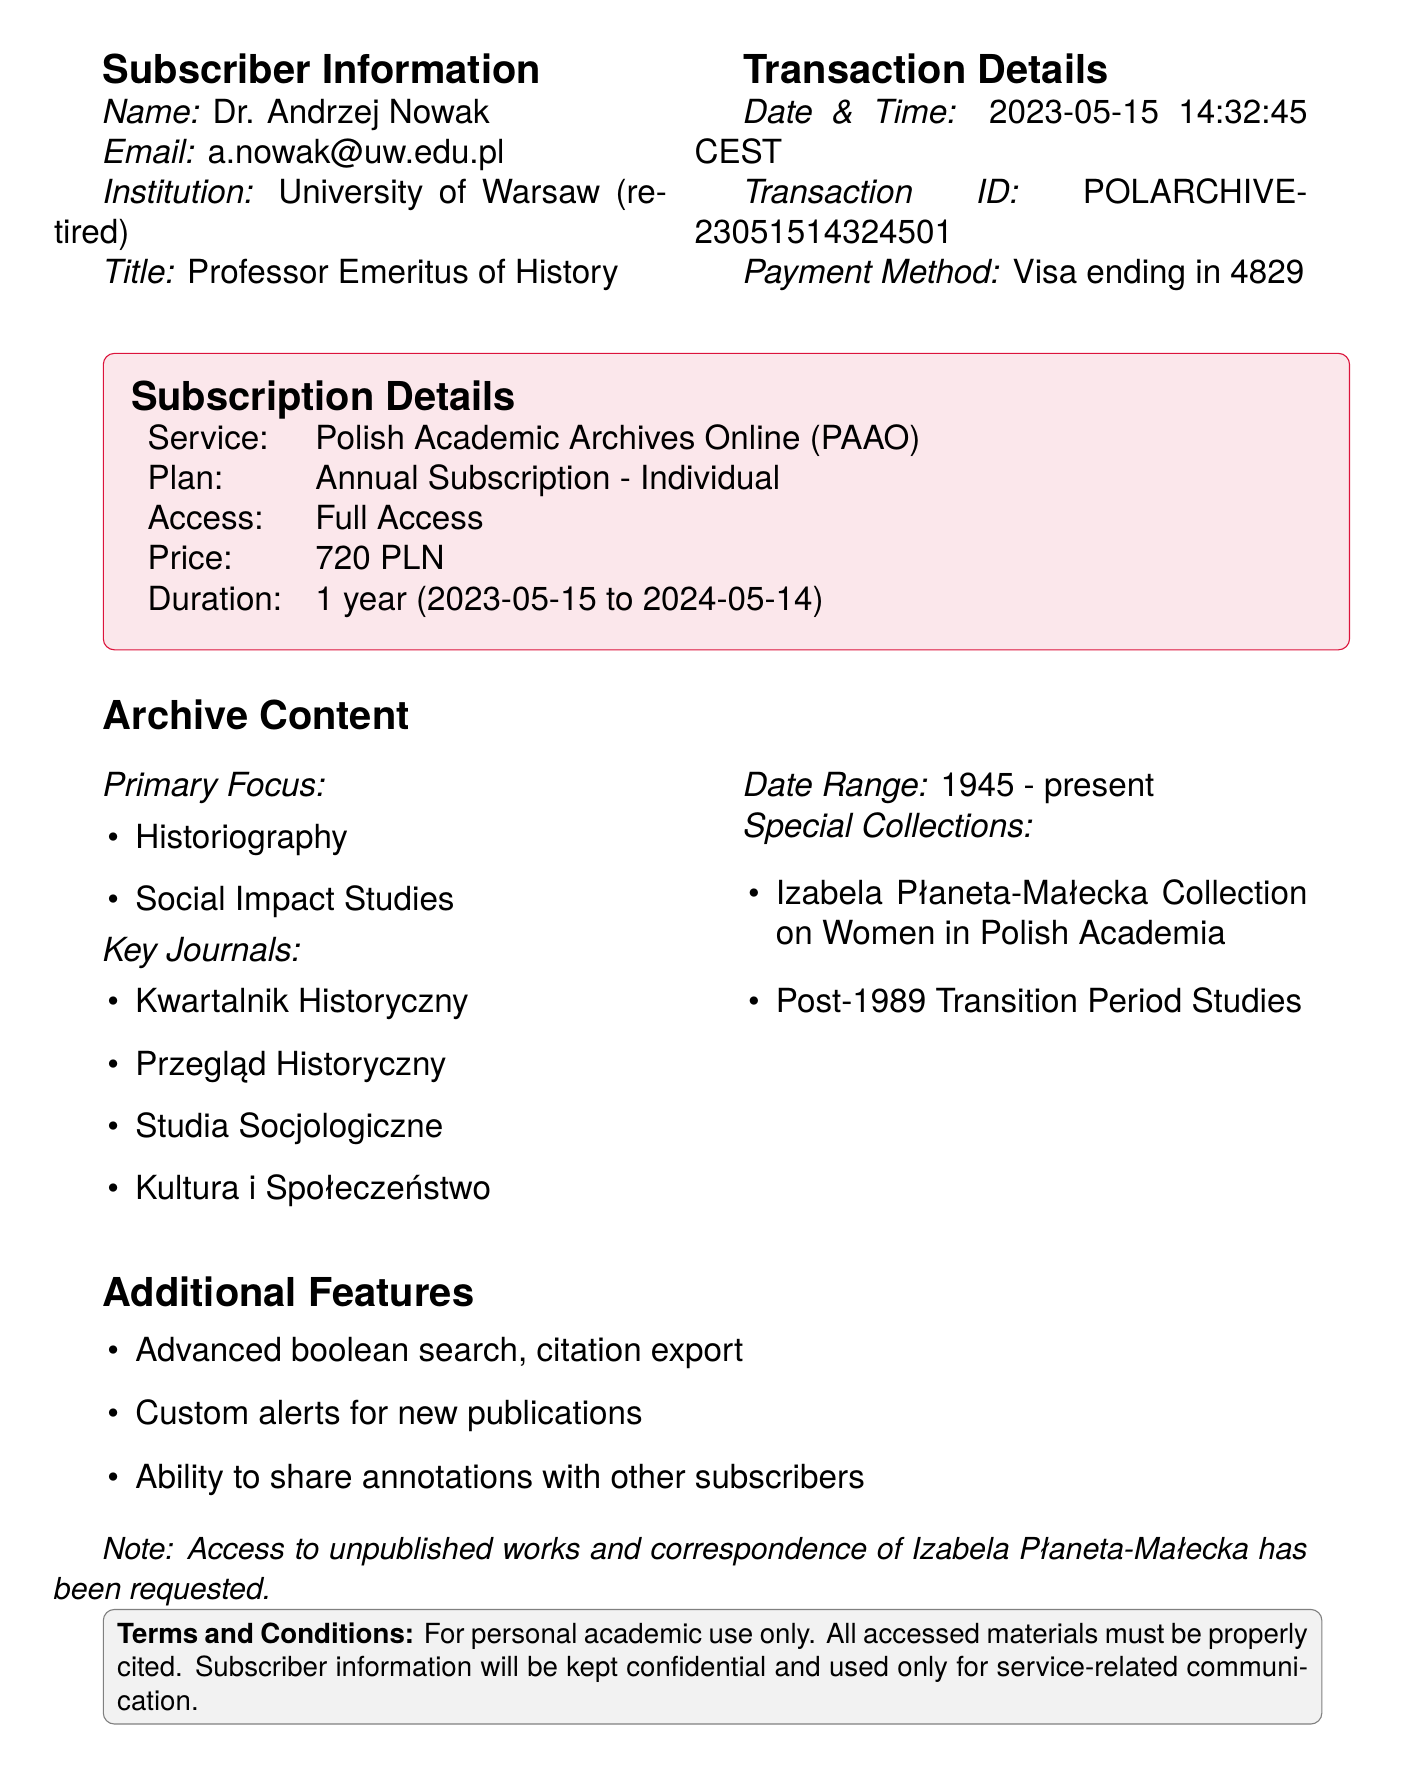What is the transaction ID? The transaction ID is listed in the transaction details section of the document, which is uniquely identifying the transaction.
Answer: POLARCHIVE-23051514324501 What is the subscription price? The price for the subscription is explicitly mentioned in the subscription details section of the document.
Answer: 720 PLN Who is the subscriber? The subscriber's name is found in the subscriber information section of the document.
Answer: Dr. Andrzej Nowak What is the access level for this subscription? The access level is specified in the subscription details of the document, indicating what can be accessed.
Answer: Full Access What research interests does the subscriber have? The research interests are listed under subscriber notes, summarizing the main areas of interest for the subscriber.
Answer: Polish academic development post-WWII What are the key journals included in the subscription? The document lists key journals in the archive content section, indicating which publications can be accessed.
Answer: Kwartalnik Historyczny, Przegląd Historyczny, Studia Socjologiczne, Kultura i Społeczeństwo What is the duration of the subscription? The duration is stated in the subscription details, providing the time frame for which the service is active.
Answer: 1 year What is the primary focus of the archive content? The primary focus areas are highlighted in the archive content section, indicating the main subjects covered by the archive.
Answer: Historiography, Social Impact Studies Is there a special request made by the subscriber? The document includes a specific request in subscriber notes, indicating additional content sought by the subscriber.
Answer: Access to unpublished works and correspondence of Izabela Płaneta-Małecka 